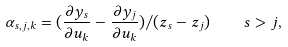<formula> <loc_0><loc_0><loc_500><loc_500>\alpha _ { s , j , k } = ( \frac { { \partial } y _ { s } } { { \partial } u _ { k } } - \frac { { \partial } y _ { j } } { { \partial } u _ { k } } ) / ( z _ { s } - z _ { j } ) \quad s > j ,</formula> 